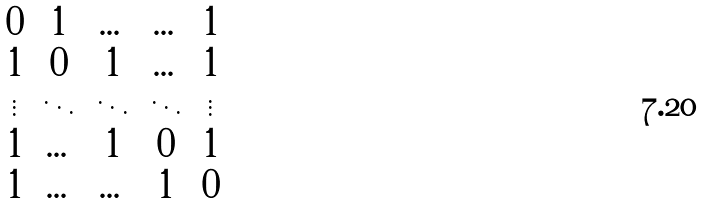Convert formula to latex. <formula><loc_0><loc_0><loc_500><loc_500>\begin{matrix} 0 & 1 & \dots & \dots & 1 \\ 1 & 0 & 1 & \dots & 1 \\ \vdots & \ddots & \ddots & \ddots & \vdots \\ 1 & \dots & 1 & 0 & 1 \\ 1 & \dots & \dots & 1 & 0 \end{matrix}</formula> 